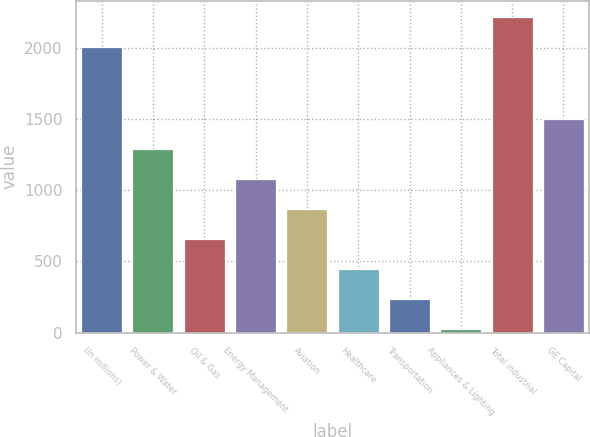Convert chart. <chart><loc_0><loc_0><loc_500><loc_500><bar_chart><fcel>(In millions)<fcel>Power & Water<fcel>Oil & Gas<fcel>Energy Management<fcel>Aviation<fcel>Healthcare<fcel>Transportation<fcel>Appliances & Lighting<fcel>Total industrial<fcel>GE Capital<nl><fcel>2011<fcel>1291<fcel>656.5<fcel>1079.5<fcel>868<fcel>445<fcel>233.5<fcel>22<fcel>2222.5<fcel>1502.5<nl></chart> 